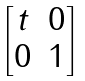<formula> <loc_0><loc_0><loc_500><loc_500>\begin{bmatrix} t & 0 \\ 0 & 1 \end{bmatrix}</formula> 